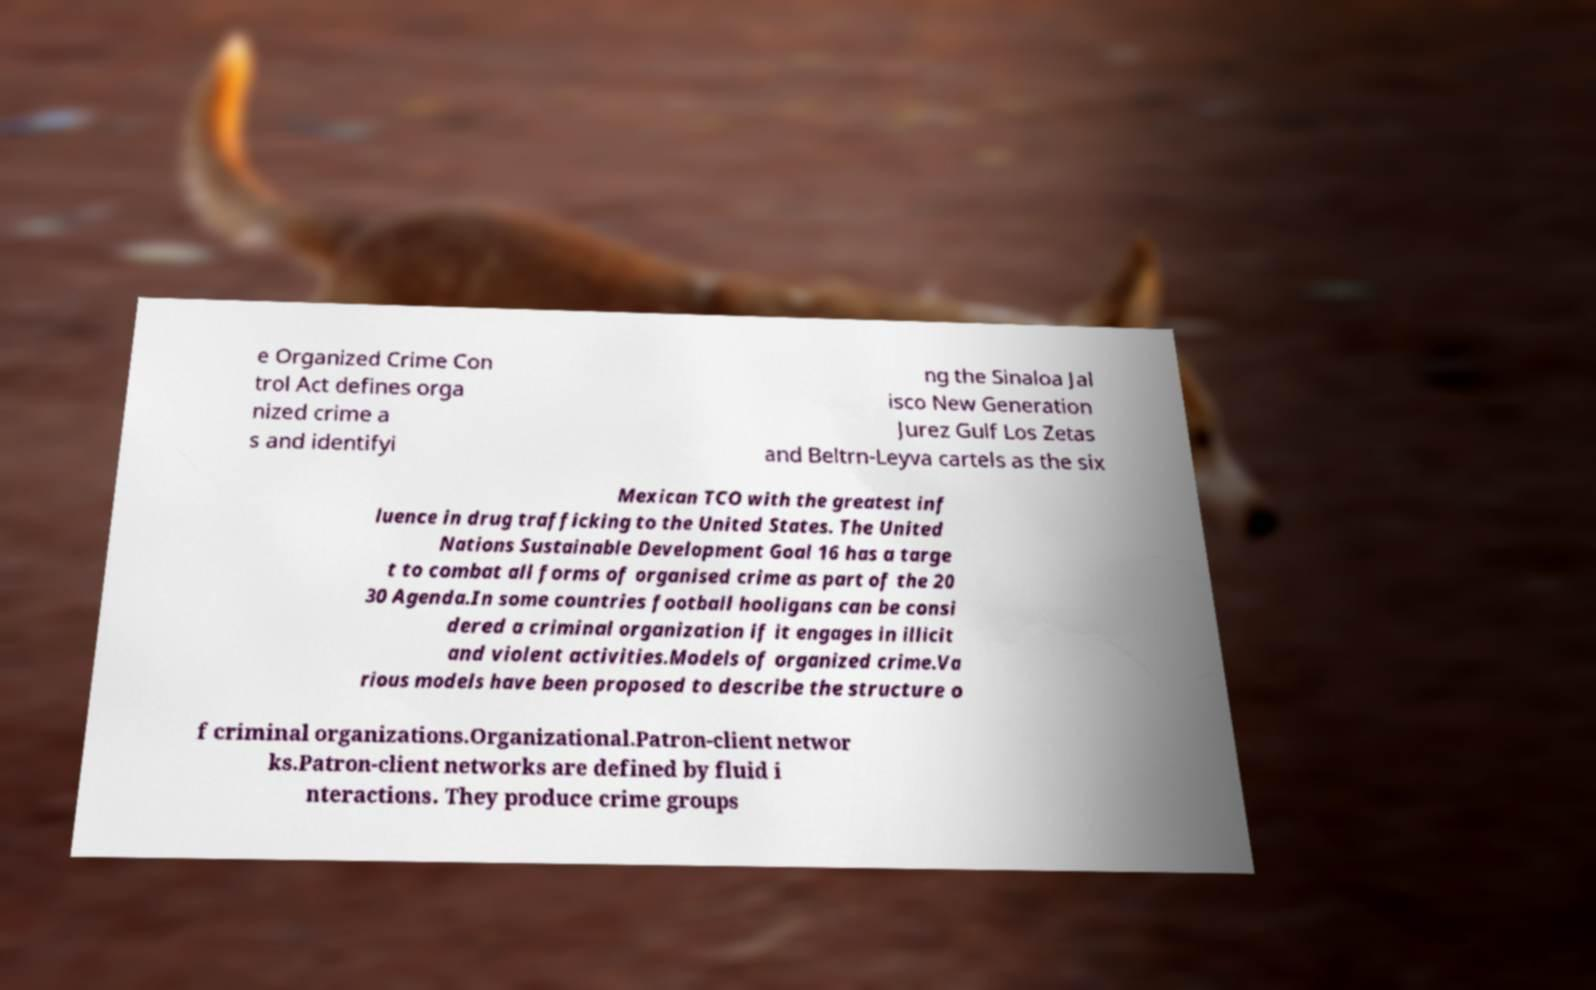Please identify and transcribe the text found in this image. e Organized Crime Con trol Act defines orga nized crime a s and identifyi ng the Sinaloa Jal isco New Generation Jurez Gulf Los Zetas and Beltrn-Leyva cartels as the six Mexican TCO with the greatest inf luence in drug trafficking to the United States. The United Nations Sustainable Development Goal 16 has a targe t to combat all forms of organised crime as part of the 20 30 Agenda.In some countries football hooligans can be consi dered a criminal organization if it engages in illicit and violent activities.Models of organized crime.Va rious models have been proposed to describe the structure o f criminal organizations.Organizational.Patron-client networ ks.Patron-client networks are defined by fluid i nteractions. They produce crime groups 